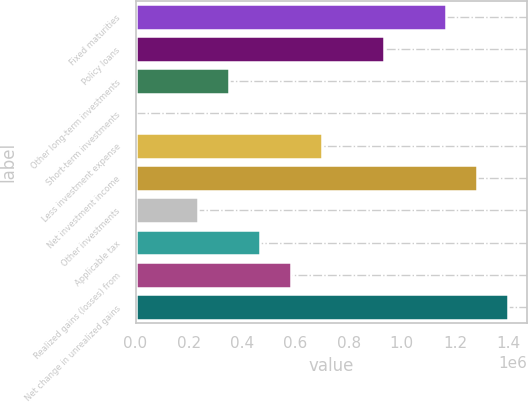Convert chart to OTSL. <chart><loc_0><loc_0><loc_500><loc_500><bar_chart><fcel>Fixed maturities<fcel>Policy loans<fcel>Other long-term investments<fcel>Short-term investments<fcel>Less investment expense<fcel>Net investment income<fcel>Other investments<fcel>Applicable tax<fcel>Realized gains (losses) from<fcel>Net change in unrealized gains<nl><fcel>1.16603e+06<fcel>932845<fcel>349876<fcel>95<fcel>699657<fcel>1.28263e+06<fcel>233282<fcel>466470<fcel>583064<fcel>1.39922e+06<nl></chart> 